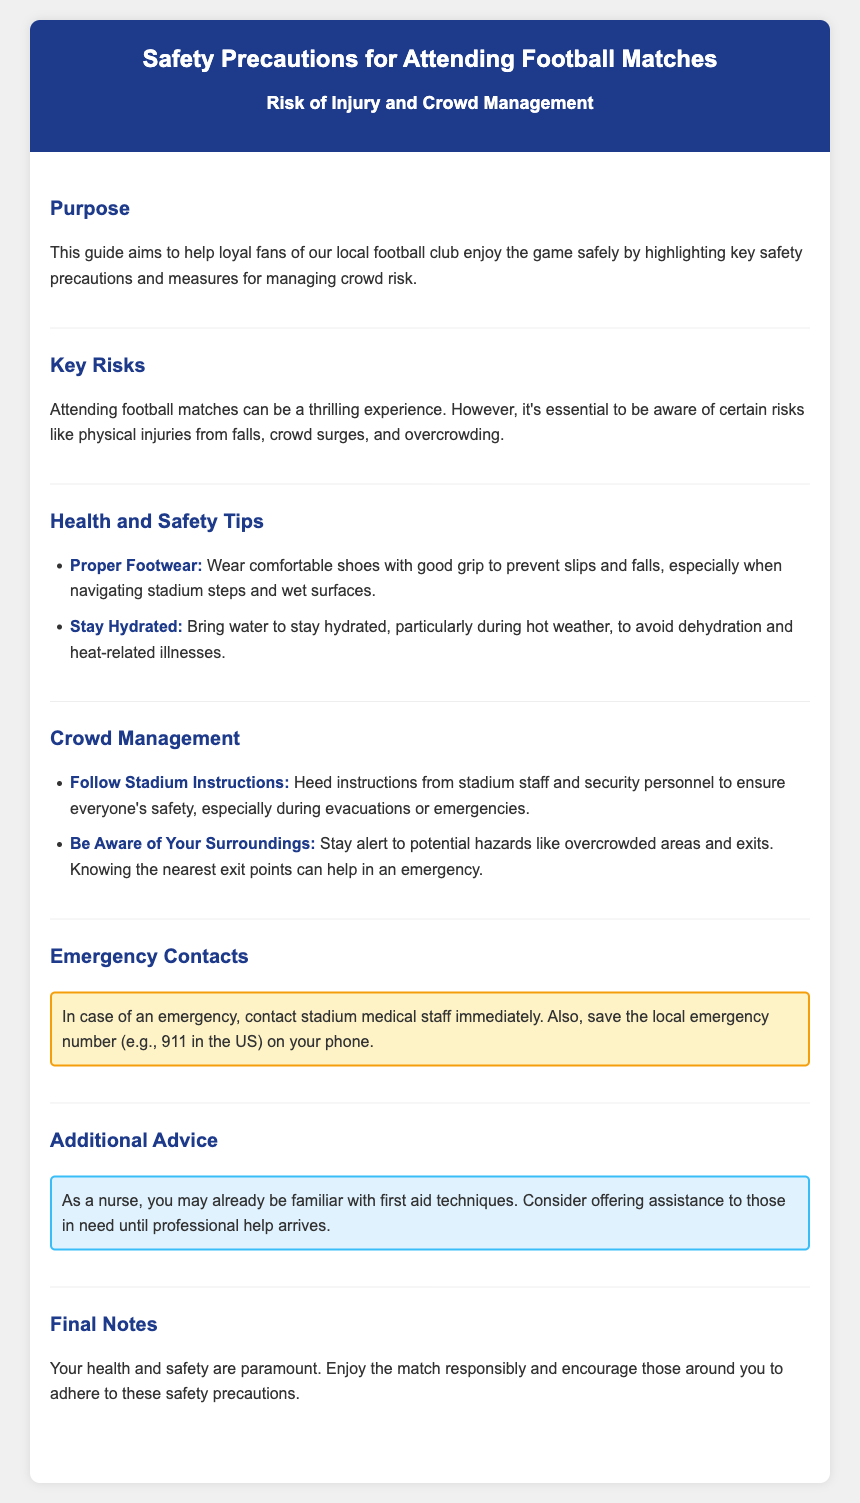What is the purpose of the guide? The guide aims to help loyal fans of our local football club enjoy the game safely by highlighting key safety precautions and measures for managing crowd risk.
Answer: Help fans enjoy the game safely What are the key risks associated with attending football matches? The key risks include physical injuries from falls, crowd surges, and overcrowding as mentioned in the document.
Answer: Falls, crowd surges, overcrowding What should you wear to prevent slips and falls? The document advises wearing comfortable shoes with good grip to prevent slips and falls, especially when navigating stadium steps and wet surfaces.
Answer: Comfortable shoes with good grip What should you do in case of an emergency? In case of an emergency, you should contact stadium medical staff immediately and save the local emergency number on your phone.
Answer: Contact stadium medical staff What advice is given to nurses attending the matches? The document advises nurses to consider offering assistance to those in need until professional help arrives.
Answer: Offer assistance until professional help arrives How can you stay hydrated at the match? The tips suggest bringing water to stay hydrated, particularly during hot weather, to avoid dehydration and heat-related illnesses.
Answer: Bring water Why is it important to follow stadium instructions? Following stadium instructions from staff and security personnel ensures everyone's safety, especially during evacuations or emergencies.
Answer: Ensures everyone's safety Where can you find the nearest exit points? Being aware of your surroundings and staying alert can help you know the nearest exit points in case of an emergency.
Answer: Know your surroundings What color is the emergency contacts section? The emergency contacts section has a background color of yellow according to the styling in the document.
Answer: Yellow 